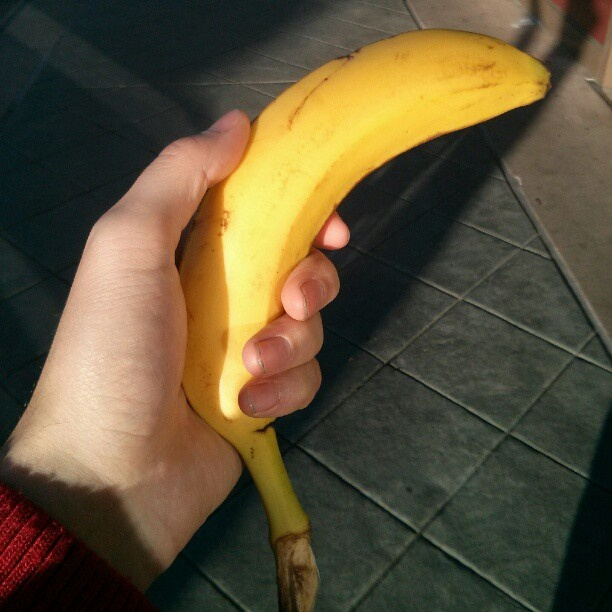Describe the objects in this image and their specific colors. I can see people in black, brown, and tan tones and banana in black, gold, orange, and olive tones in this image. 